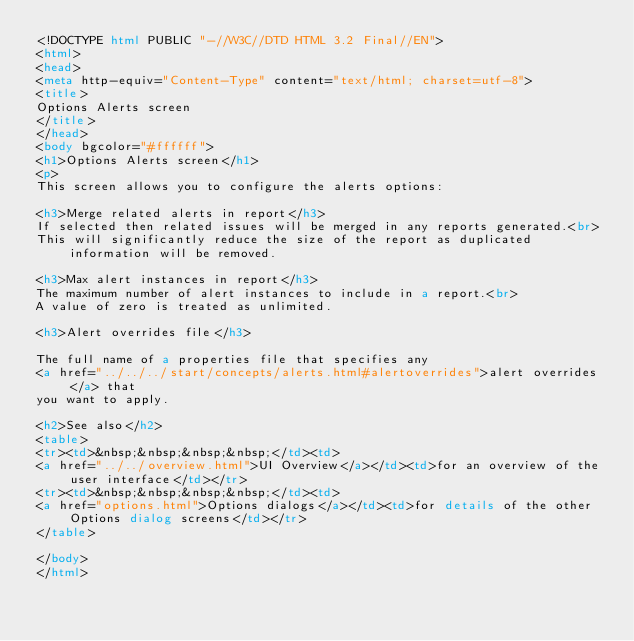Convert code to text. <code><loc_0><loc_0><loc_500><loc_500><_HTML_><!DOCTYPE html PUBLIC "-//W3C//DTD HTML 3.2 Final//EN">
<html>
<head>
<meta http-equiv="Content-Type" content="text/html; charset=utf-8">
<title>
Options Alerts screen
</title>
</head>
<body bgcolor="#ffffff">
<h1>Options Alerts screen</h1>
<p>
This screen allows you to configure the alerts options:

<h3>Merge related alerts in report</h3>
If selected then related issues will be merged in any reports generated.<br>
This will significantly reduce the size of the report as duplicated information will be removed.

<h3>Max alert instances in report</h3>
The maximum number of alert instances to include in a report.<br>
A value of zero is treated as unlimited. 

<h3>Alert overrides file</h3>

The full name of a properties file that specifies any
<a href="../../../start/concepts/alerts.html#alertoverrides">alert overrides</a> that
you want to apply.

<h2>See also</h2>
<table>
<tr><td>&nbsp;&nbsp;&nbsp;&nbsp;</td><td>
<a href="../../overview.html">UI Overview</a></td><td>for an overview of the user interface</td></tr>
<tr><td>&nbsp;&nbsp;&nbsp;&nbsp;</td><td>
<a href="options.html">Options dialogs</a></td><td>for details of the other Options dialog screens</td></tr>
</table>

</body>
</html>
</code> 